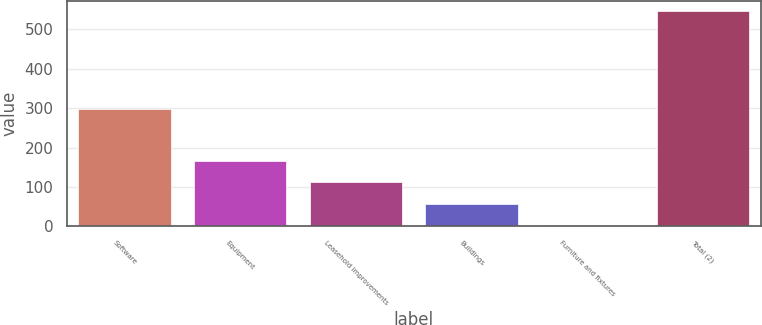Convert chart. <chart><loc_0><loc_0><loc_500><loc_500><bar_chart><fcel>Software<fcel>Equipment<fcel>Leasehold improvements<fcel>Buildings<fcel>Furniture and fixtures<fcel>Total (2)<nl><fcel>297<fcel>165.9<fcel>111.6<fcel>57.3<fcel>3<fcel>546<nl></chart> 